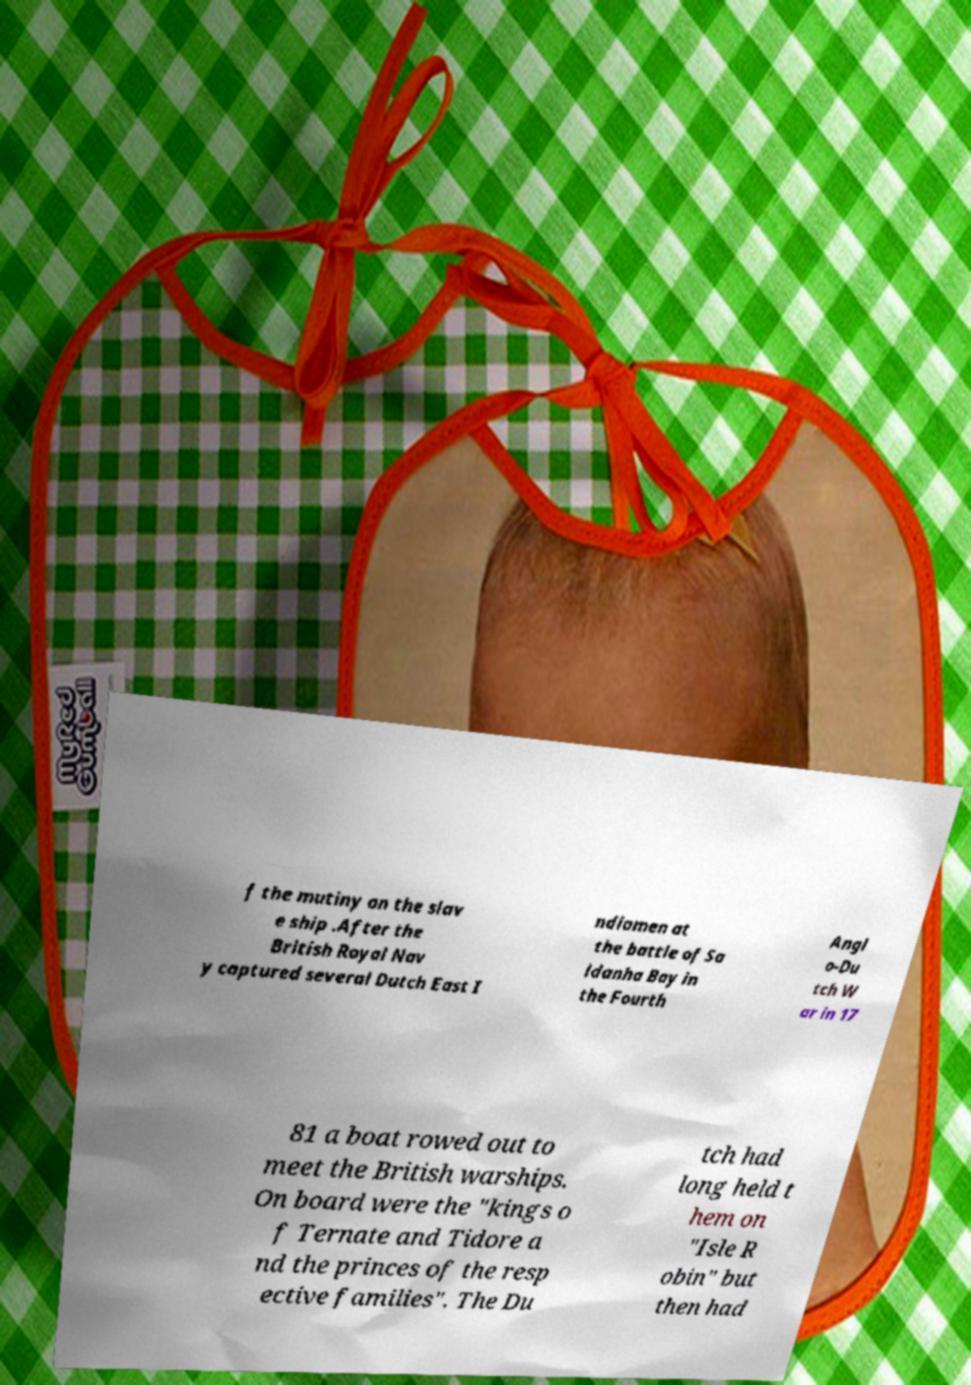Please read and relay the text visible in this image. What does it say? f the mutiny on the slav e ship .After the British Royal Nav y captured several Dutch East I ndiamen at the battle of Sa ldanha Bay in the Fourth Angl o-Du tch W ar in 17 81 a boat rowed out to meet the British warships. On board were the "kings o f Ternate and Tidore a nd the princes of the resp ective families". The Du tch had long held t hem on "Isle R obin" but then had 